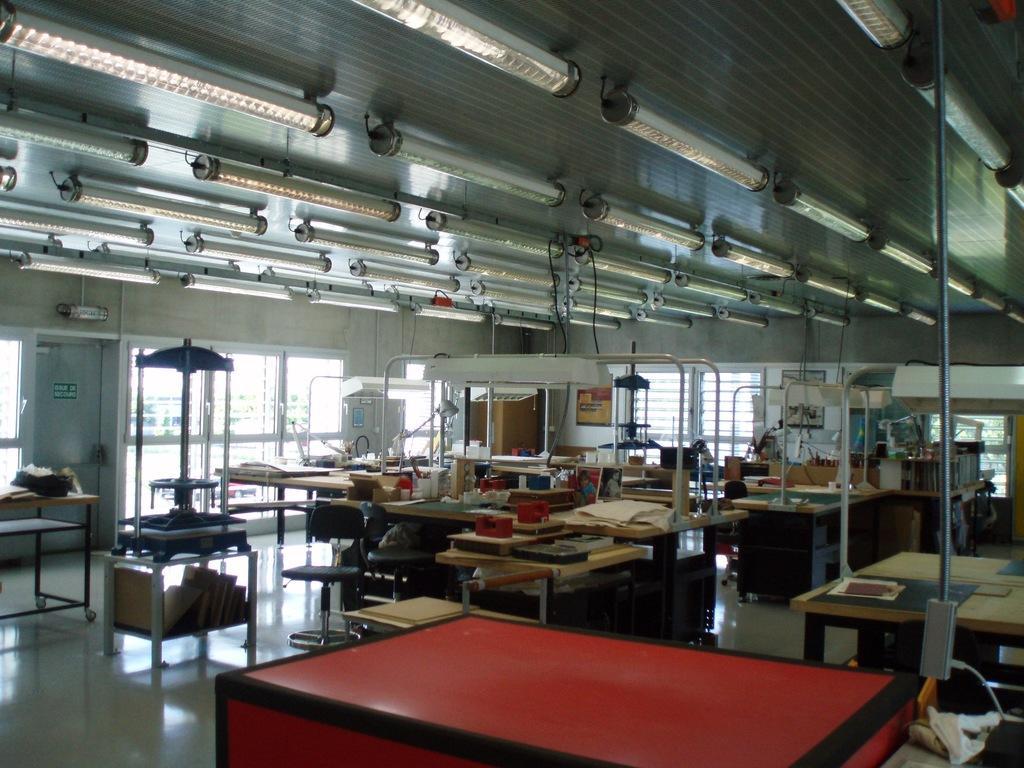Could you give a brief overview of what you see in this image? This is an inside view of a room. There are many tables on the floor. On the tables, I can see few boxes, machines and many other objects. There are many poles. At the top of the image I can see the lights attached to the ceiling. In the background there are glass doors through which we can see the outside view. 